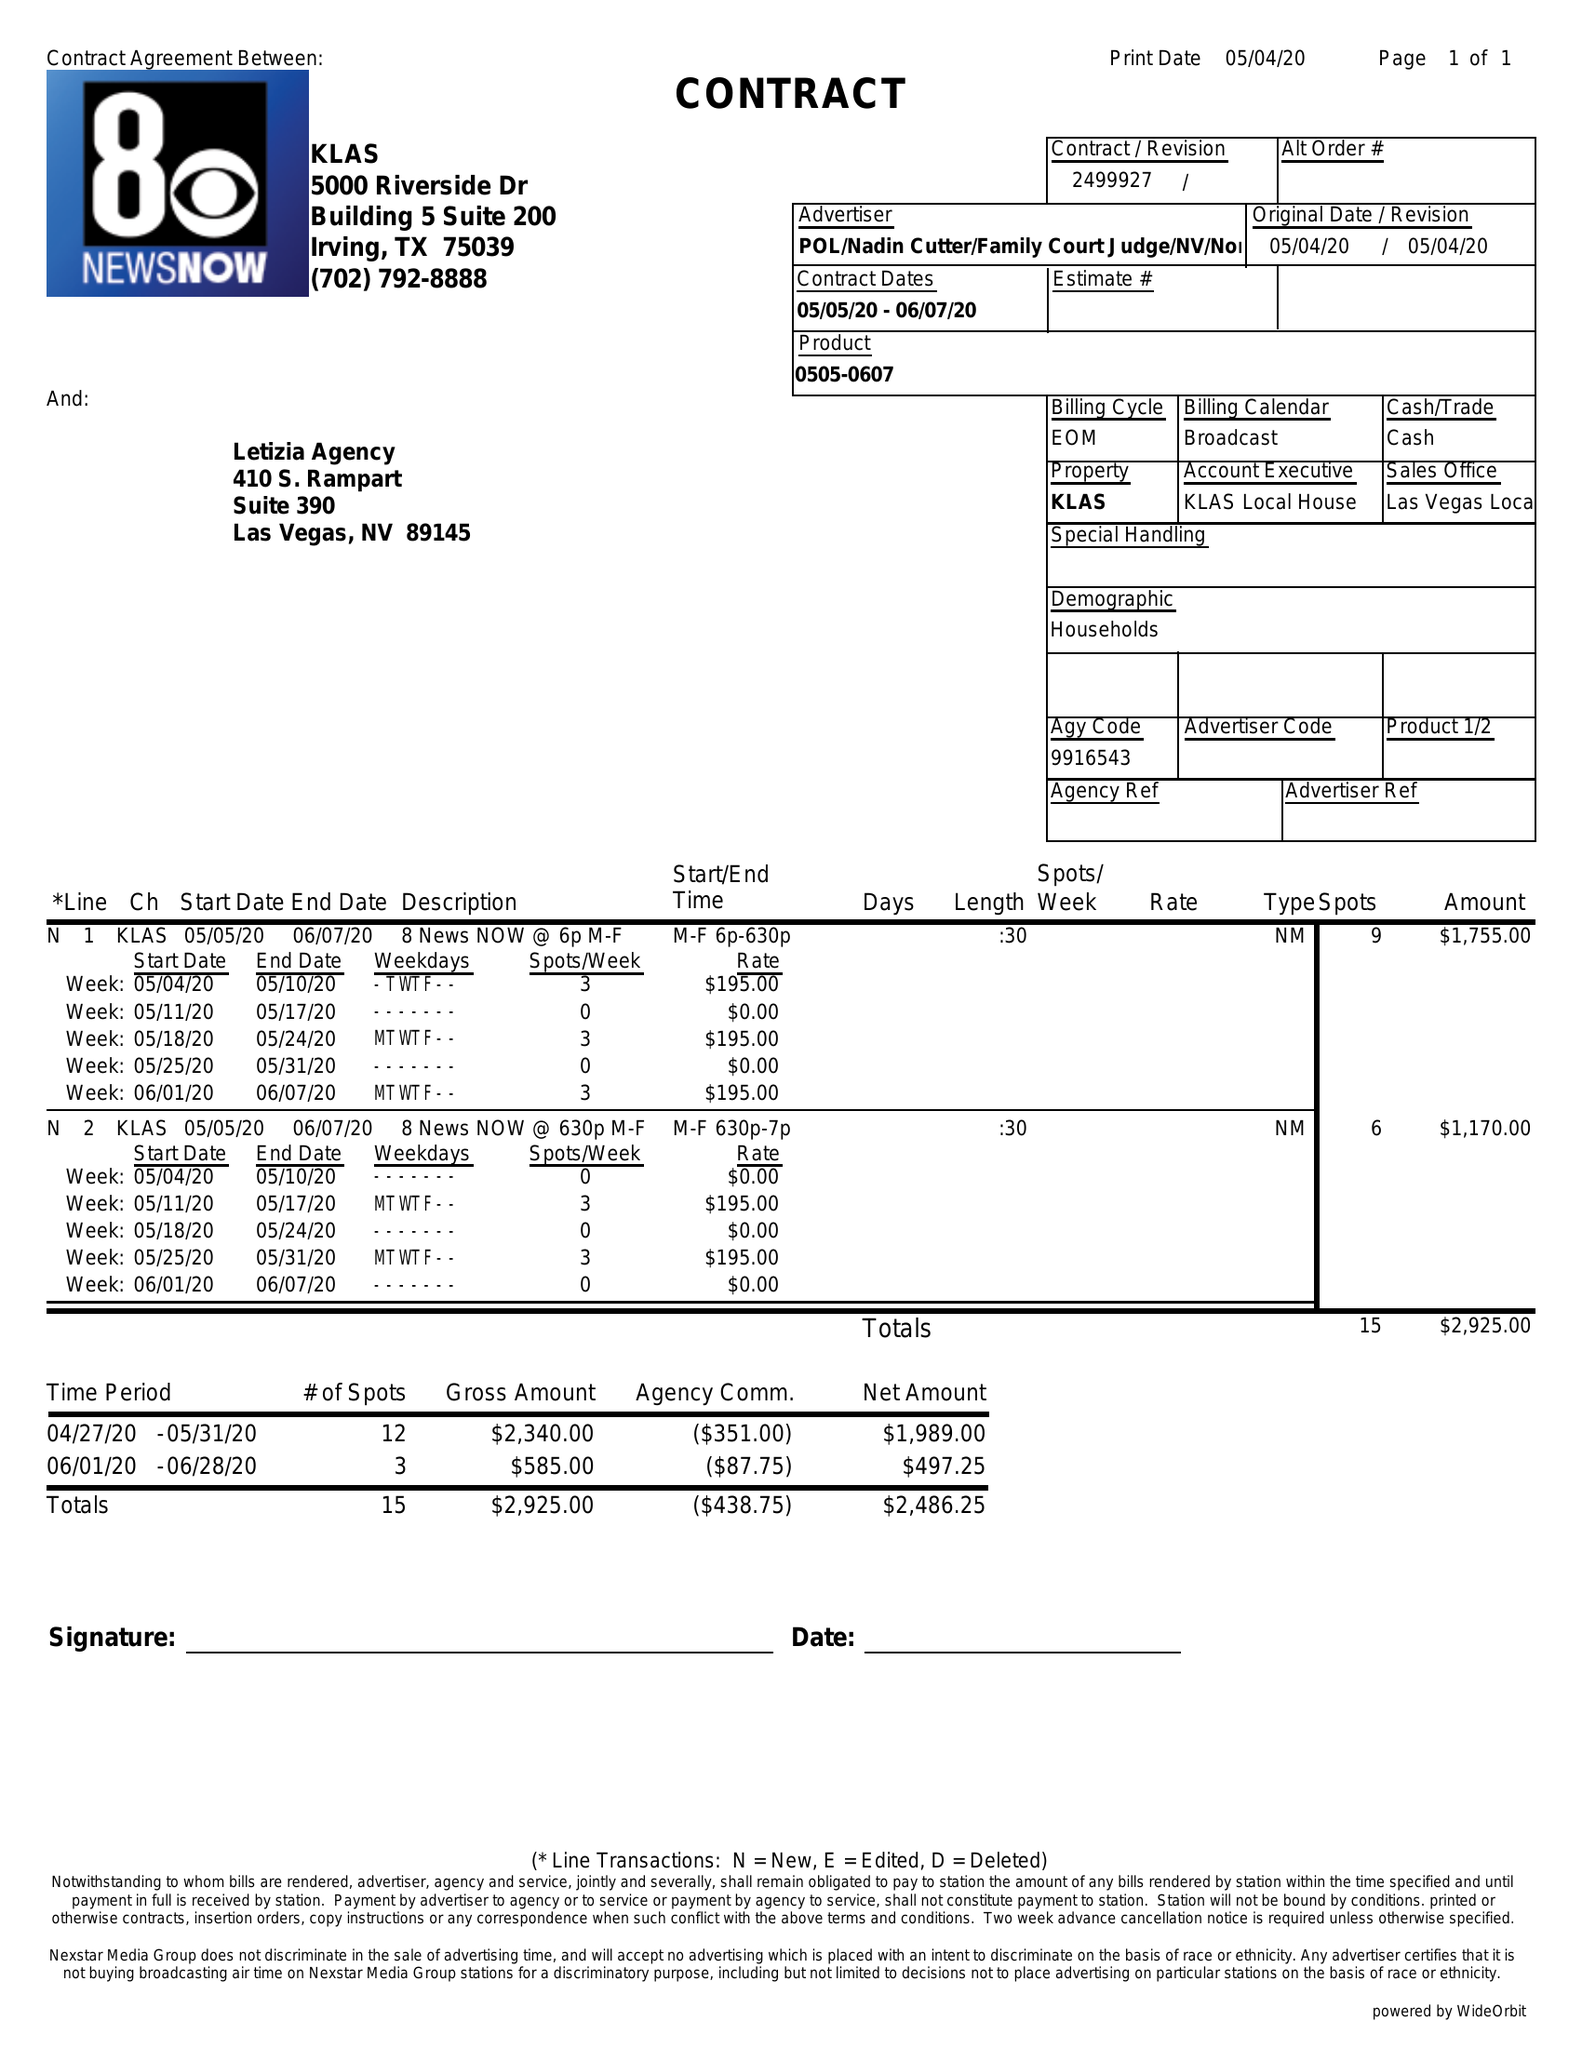What is the value for the flight_to?
Answer the question using a single word or phrase. 06/07/20 